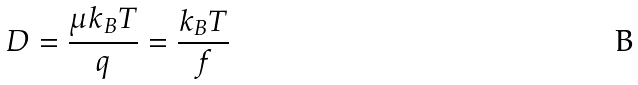<formula> <loc_0><loc_0><loc_500><loc_500>D = \frac { \mu k _ { B } T } { q } = \frac { k _ { B } T } { f }</formula> 